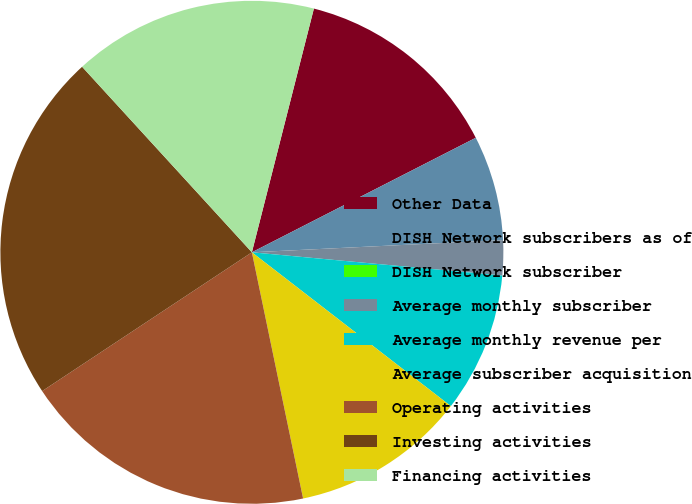<chart> <loc_0><loc_0><loc_500><loc_500><pie_chart><fcel>Other Data<fcel>DISH Network subscribers as of<fcel>DISH Network subscriber<fcel>Average monthly subscriber<fcel>Average monthly revenue per<fcel>Average subscriber acquisition<fcel>Operating activities<fcel>Investing activities<fcel>Financing activities<nl><fcel>13.51%<fcel>6.75%<fcel>0.0%<fcel>2.25%<fcel>9.0%<fcel>11.26%<fcel>18.96%<fcel>22.51%<fcel>15.76%<nl></chart> 